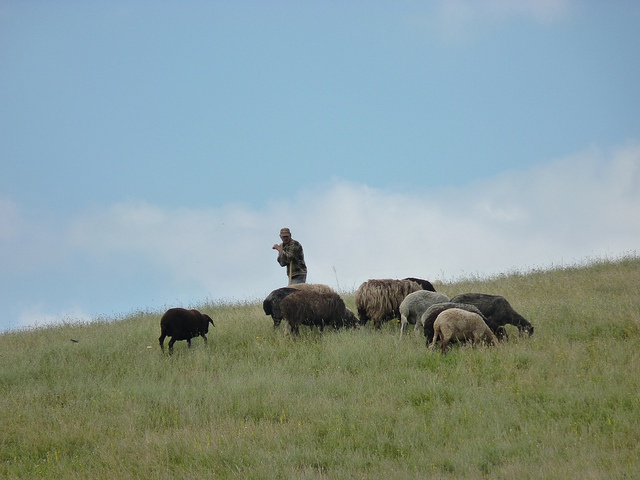Describe the objects in this image and their specific colors. I can see sheep in darkgray, black, and gray tones, sheep in darkgray, gray, and black tones, sheep in darkgray, gray, and black tones, sheep in darkgray, black, gray, darkgreen, and olive tones, and sheep in darkgray, black, and gray tones in this image. 